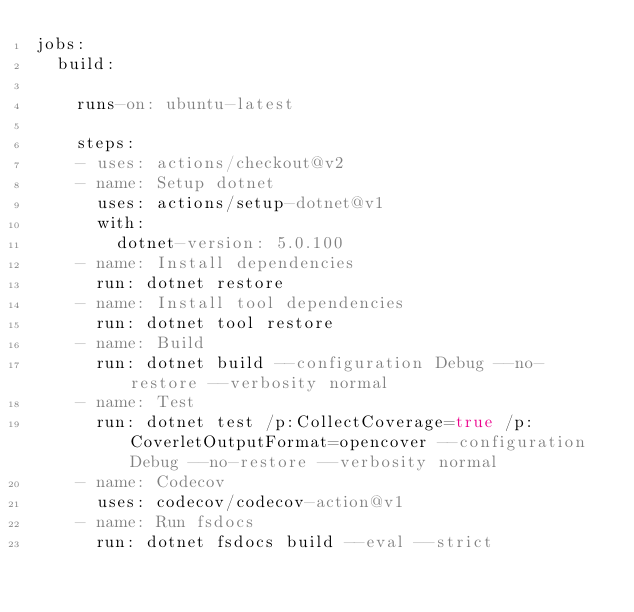Convert code to text. <code><loc_0><loc_0><loc_500><loc_500><_YAML_>jobs:
  build:

    runs-on: ubuntu-latest

    steps:
    - uses: actions/checkout@v2
    - name: Setup dotnet
      uses: actions/setup-dotnet@v1
      with:
        dotnet-version: 5.0.100
    - name: Install dependencies
      run: dotnet restore
    - name: Install tool dependencies
      run: dotnet tool restore
    - name: Build
      run: dotnet build --configuration Debug --no-restore --verbosity normal
    - name: Test
      run: dotnet test /p:CollectCoverage=true /p:CoverletOutputFormat=opencover --configuration Debug --no-restore --verbosity normal
    - name: Codecov
      uses: codecov/codecov-action@v1
    - name: Run fsdocs
      run: dotnet fsdocs build --eval --strict
</code> 